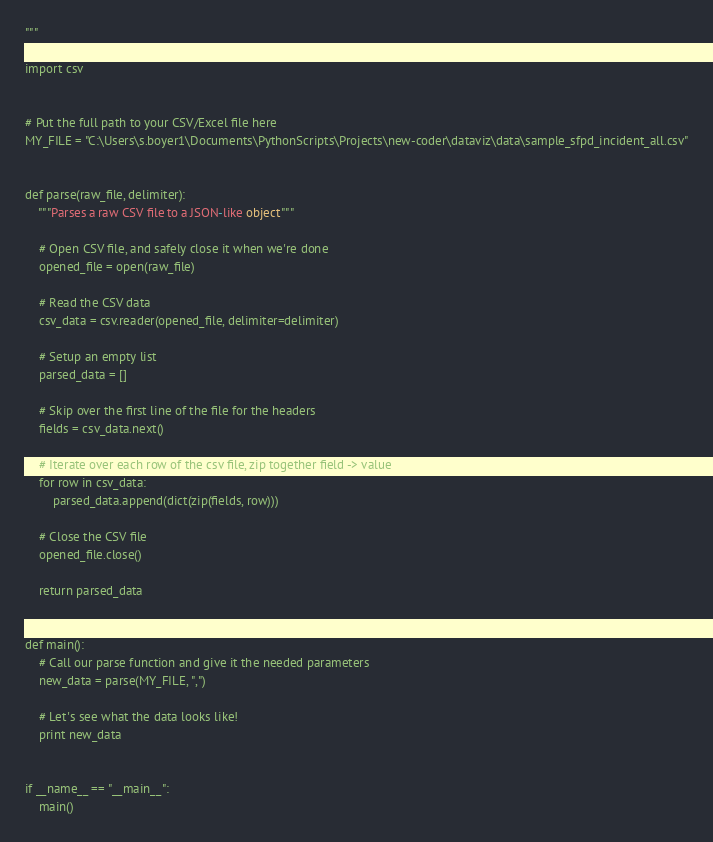Convert code to text. <code><loc_0><loc_0><loc_500><loc_500><_Python_>"""

import csv


# Put the full path to your CSV/Excel file here
MY_FILE = "C:\Users\s.boyer1\Documents\PythonScripts\Projects\new-coder\dataviz\data\sample_sfpd_incident_all.csv"


def parse(raw_file, delimiter):
    """Parses a raw CSV file to a JSON-like object"""

    # Open CSV file, and safely close it when we're done
    opened_file = open(raw_file)
    
    # Read the CSV data
    csv_data = csv.reader(opened_file, delimiter=delimiter)

    # Setup an empty list
    parsed_data = []

    # Skip over the first line of the file for the headers
    fields = csv_data.next()

    # Iterate over each row of the csv file, zip together field -> value
    for row in csv_data:
        parsed_data.append(dict(zip(fields, row)))

    # Close the CSV file
    opened_file.close()

    return parsed_data


def main():
    # Call our parse function and give it the needed parameters
    new_data = parse(MY_FILE, ",")

    # Let's see what the data looks like!
    print new_data


if __name__ == "__main__":
    main()
</code> 